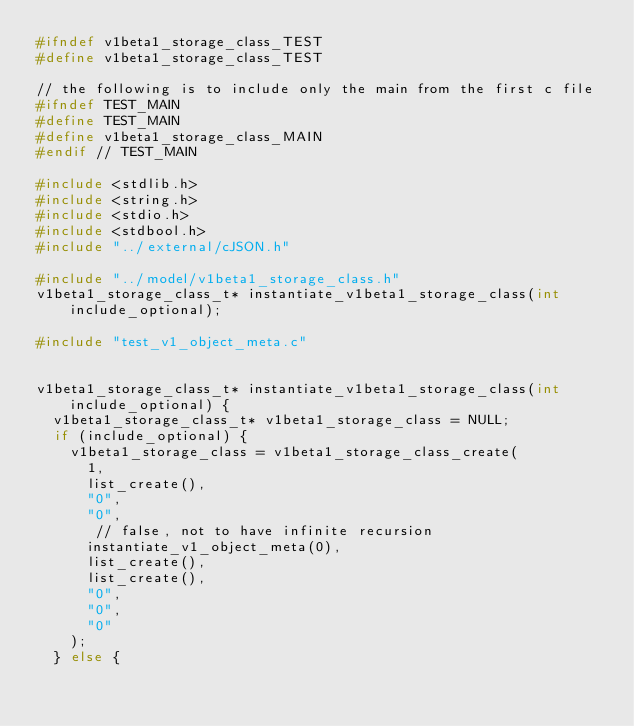<code> <loc_0><loc_0><loc_500><loc_500><_C_>#ifndef v1beta1_storage_class_TEST
#define v1beta1_storage_class_TEST

// the following is to include only the main from the first c file
#ifndef TEST_MAIN
#define TEST_MAIN
#define v1beta1_storage_class_MAIN
#endif // TEST_MAIN

#include <stdlib.h>
#include <string.h>
#include <stdio.h>
#include <stdbool.h>
#include "../external/cJSON.h"

#include "../model/v1beta1_storage_class.h"
v1beta1_storage_class_t* instantiate_v1beta1_storage_class(int include_optional);

#include "test_v1_object_meta.c"


v1beta1_storage_class_t* instantiate_v1beta1_storage_class(int include_optional) {
  v1beta1_storage_class_t* v1beta1_storage_class = NULL;
  if (include_optional) {
    v1beta1_storage_class = v1beta1_storage_class_create(
      1,
      list_create(),
      "0",
      "0",
       // false, not to have infinite recursion
      instantiate_v1_object_meta(0),
      list_create(),
      list_create(),
      "0",
      "0",
      "0"
    );
  } else {</code> 